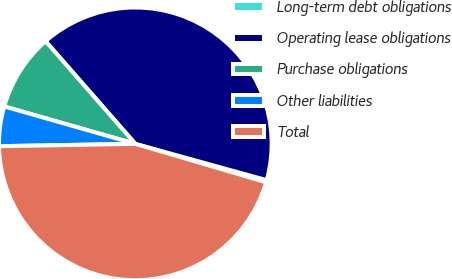<chart> <loc_0><loc_0><loc_500><loc_500><pie_chart><fcel>Long-term debt obligations<fcel>Operating lease obligations<fcel>Purchase obligations<fcel>Other liabilities<fcel>Total<nl><fcel>0.26%<fcel>40.73%<fcel>9.14%<fcel>4.7%<fcel>45.17%<nl></chart> 